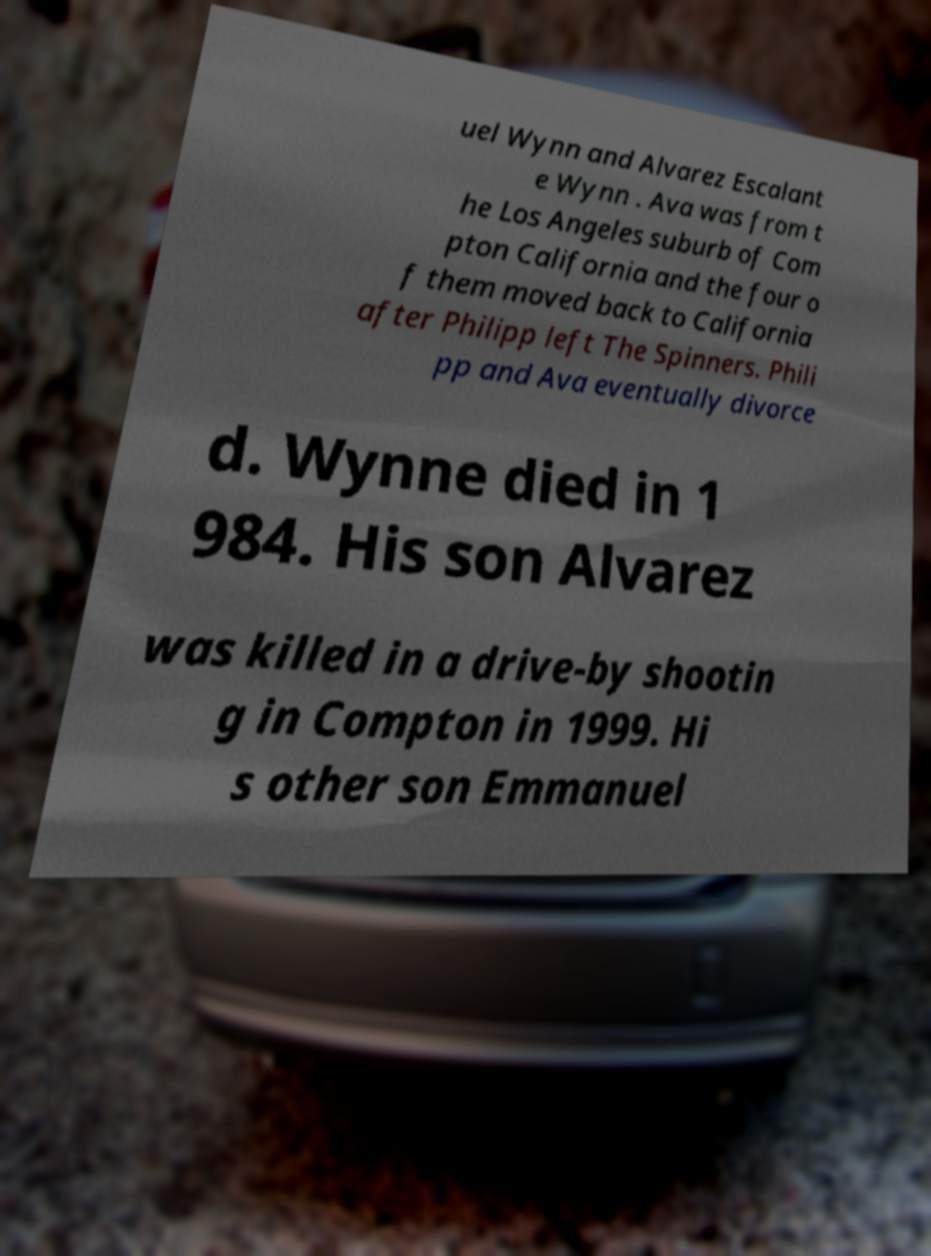For documentation purposes, I need the text within this image transcribed. Could you provide that? uel Wynn and Alvarez Escalant e Wynn . Ava was from t he Los Angeles suburb of Com pton California and the four o f them moved back to California after Philipp left The Spinners. Phili pp and Ava eventually divorce d. Wynne died in 1 984. His son Alvarez was killed in a drive-by shootin g in Compton in 1999. Hi s other son Emmanuel 